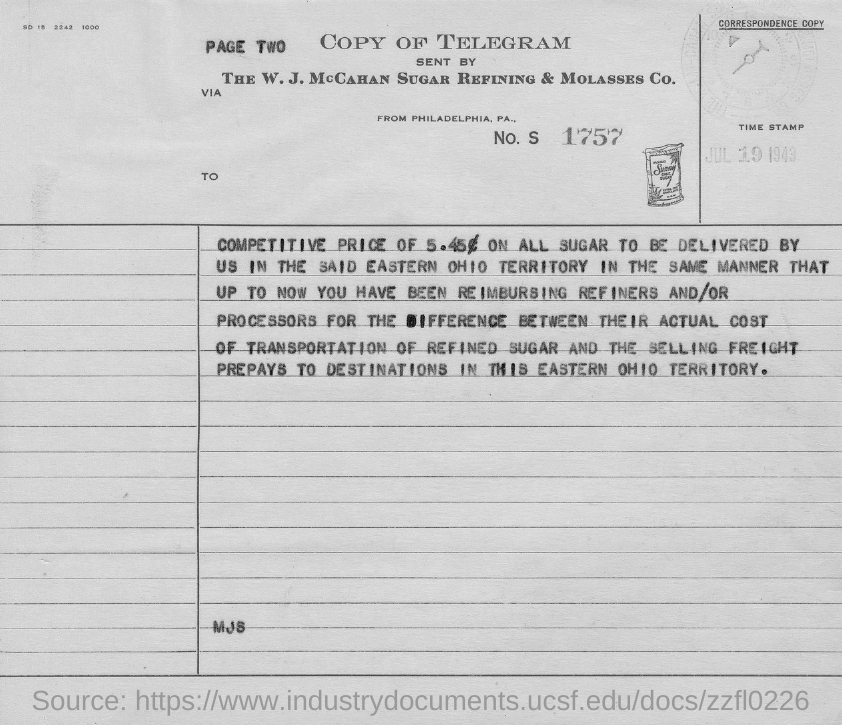What type of document is it?
Your answer should be compact. Copy of Telegram. Which city is the telegram from?
Offer a very short reply. Philadelphia, PA. What is the date stamped?
Your response must be concise. JUL 19 1943. 